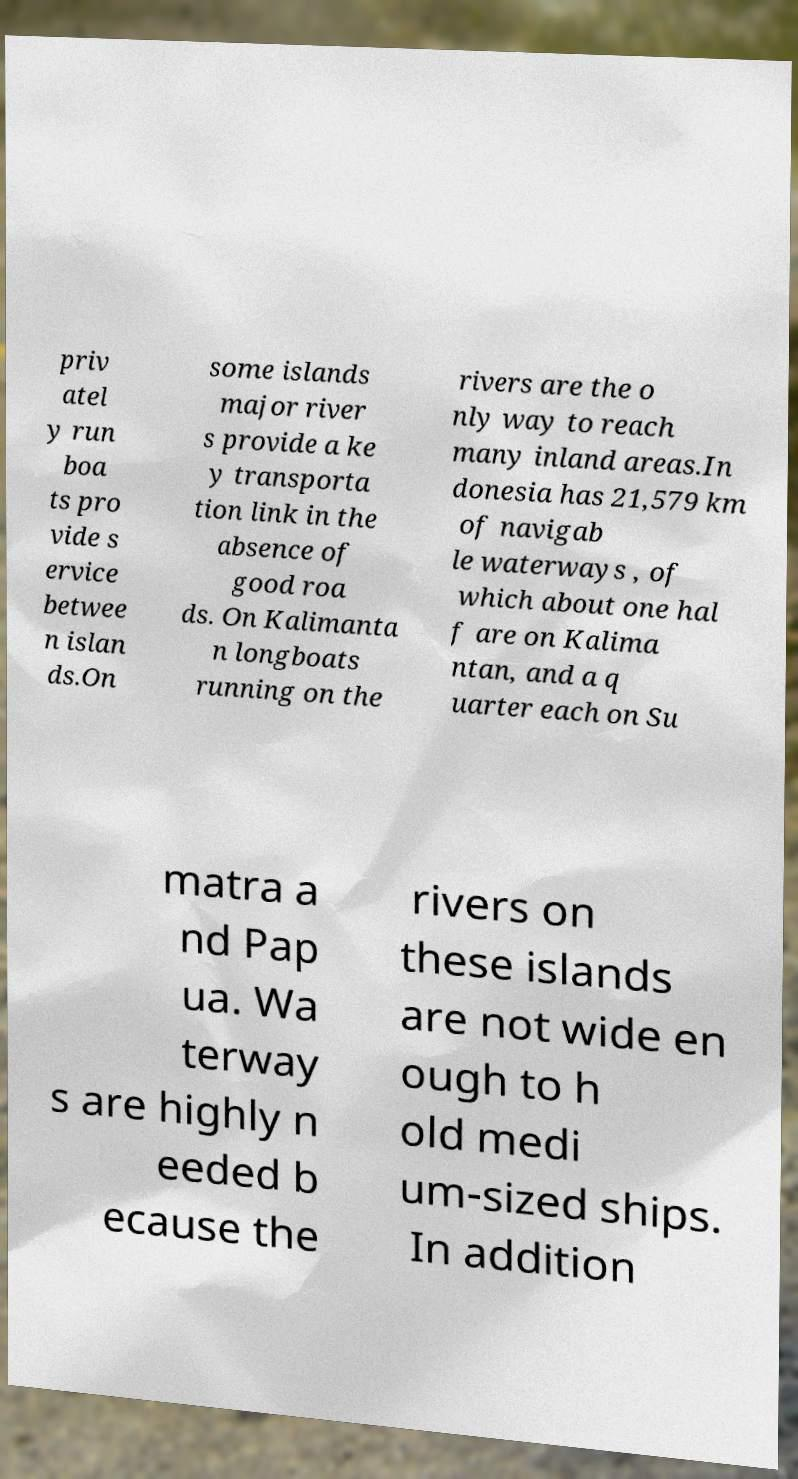I need the written content from this picture converted into text. Can you do that? priv atel y run boa ts pro vide s ervice betwee n islan ds.On some islands major river s provide a ke y transporta tion link in the absence of good roa ds. On Kalimanta n longboats running on the rivers are the o nly way to reach many inland areas.In donesia has 21,579 km of navigab le waterways , of which about one hal f are on Kalima ntan, and a q uarter each on Su matra a nd Pap ua. Wa terway s are highly n eeded b ecause the rivers on these islands are not wide en ough to h old medi um-sized ships. In addition 